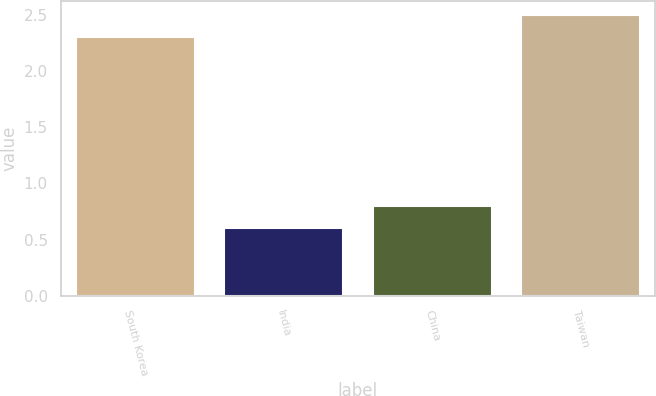<chart> <loc_0><loc_0><loc_500><loc_500><bar_chart><fcel>South Korea<fcel>India<fcel>China<fcel>Taiwan<nl><fcel>2.3<fcel>0.6<fcel>0.8<fcel>2.5<nl></chart> 